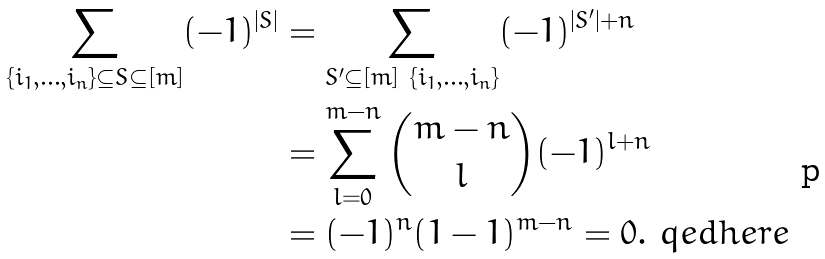Convert formula to latex. <formula><loc_0><loc_0><loc_500><loc_500>\sum _ { \{ i _ { 1 } , \dots , i _ { n } \} \subseteq S \subseteq [ m ] } ( - 1 ) ^ { | S | } & = \sum _ { S ^ { \prime } \subseteq [ m ] \ \{ i _ { 1 } , \dots , i _ { n } \} } ( - 1 ) ^ { | S ^ { \prime } | + n } \\ & = \sum _ { l = 0 } ^ { m - n } { m - n \choose l } ( - 1 ) ^ { l + n } \\ & = ( - 1 ) ^ { n } ( 1 - 1 ) ^ { m - n } = 0 . \ q e d h e r e</formula> 